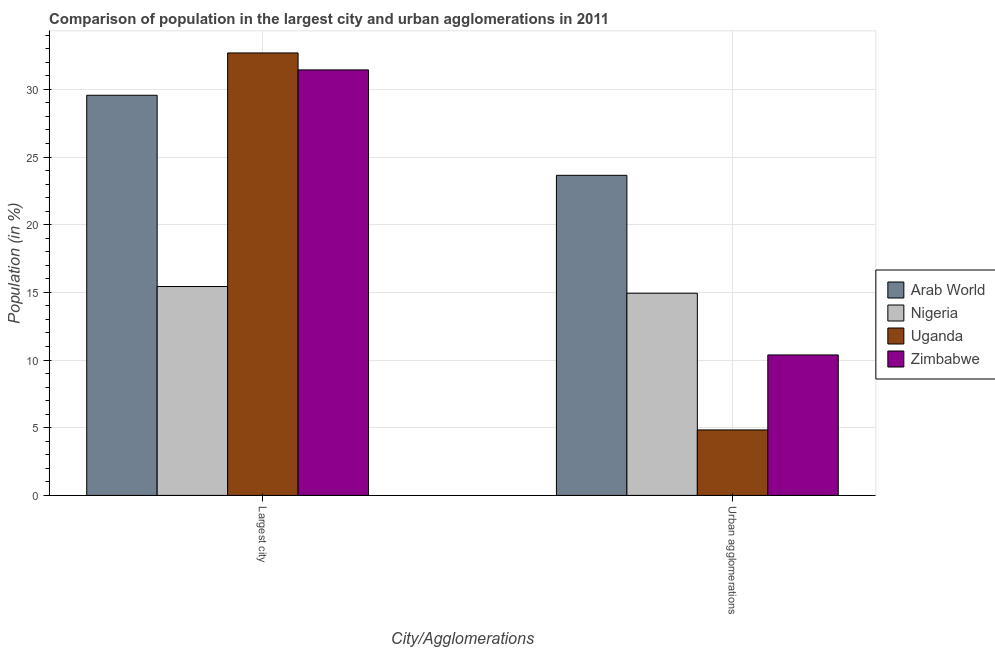Are the number of bars on each tick of the X-axis equal?
Provide a short and direct response. Yes. What is the label of the 1st group of bars from the left?
Your answer should be very brief. Largest city. What is the population in the largest city in Uganda?
Ensure brevity in your answer.  32.69. Across all countries, what is the maximum population in urban agglomerations?
Offer a terse response. 23.65. Across all countries, what is the minimum population in urban agglomerations?
Offer a terse response. 4.84. In which country was the population in the largest city maximum?
Your response must be concise. Uganda. In which country was the population in urban agglomerations minimum?
Offer a very short reply. Uganda. What is the total population in the largest city in the graph?
Your answer should be compact. 109.12. What is the difference between the population in urban agglomerations in Arab World and that in Uganda?
Your answer should be compact. 18.81. What is the difference between the population in the largest city in Arab World and the population in urban agglomerations in Uganda?
Your answer should be very brief. 24.73. What is the average population in the largest city per country?
Offer a terse response. 27.28. What is the difference between the population in urban agglomerations and population in the largest city in Nigeria?
Give a very brief answer. -0.5. What is the ratio of the population in urban agglomerations in Zimbabwe to that in Uganda?
Provide a short and direct response. 2.15. What does the 1st bar from the left in Largest city represents?
Provide a succinct answer. Arab World. What does the 1st bar from the right in Urban agglomerations represents?
Provide a short and direct response. Zimbabwe. How many bars are there?
Ensure brevity in your answer.  8. Are all the bars in the graph horizontal?
Give a very brief answer. No. How many countries are there in the graph?
Provide a succinct answer. 4. Does the graph contain grids?
Provide a succinct answer. Yes. How many legend labels are there?
Make the answer very short. 4. How are the legend labels stacked?
Your answer should be very brief. Vertical. What is the title of the graph?
Your answer should be very brief. Comparison of population in the largest city and urban agglomerations in 2011. What is the label or title of the X-axis?
Provide a short and direct response. City/Agglomerations. What is the label or title of the Y-axis?
Keep it short and to the point. Population (in %). What is the Population (in %) in Arab World in Largest city?
Give a very brief answer. 29.56. What is the Population (in %) of Nigeria in Largest city?
Offer a terse response. 15.43. What is the Population (in %) of Uganda in Largest city?
Give a very brief answer. 32.69. What is the Population (in %) in Zimbabwe in Largest city?
Your answer should be very brief. 31.44. What is the Population (in %) in Arab World in Urban agglomerations?
Give a very brief answer. 23.65. What is the Population (in %) of Nigeria in Urban agglomerations?
Your answer should be compact. 14.94. What is the Population (in %) in Uganda in Urban agglomerations?
Offer a very short reply. 4.84. What is the Population (in %) of Zimbabwe in Urban agglomerations?
Keep it short and to the point. 10.38. Across all City/Agglomerations, what is the maximum Population (in %) of Arab World?
Your response must be concise. 29.56. Across all City/Agglomerations, what is the maximum Population (in %) in Nigeria?
Keep it short and to the point. 15.43. Across all City/Agglomerations, what is the maximum Population (in %) in Uganda?
Offer a terse response. 32.69. Across all City/Agglomerations, what is the maximum Population (in %) of Zimbabwe?
Provide a succinct answer. 31.44. Across all City/Agglomerations, what is the minimum Population (in %) in Arab World?
Keep it short and to the point. 23.65. Across all City/Agglomerations, what is the minimum Population (in %) of Nigeria?
Make the answer very short. 14.94. Across all City/Agglomerations, what is the minimum Population (in %) of Uganda?
Make the answer very short. 4.84. Across all City/Agglomerations, what is the minimum Population (in %) in Zimbabwe?
Your response must be concise. 10.38. What is the total Population (in %) of Arab World in the graph?
Your answer should be compact. 53.21. What is the total Population (in %) in Nigeria in the graph?
Provide a short and direct response. 30.37. What is the total Population (in %) in Uganda in the graph?
Keep it short and to the point. 37.53. What is the total Population (in %) of Zimbabwe in the graph?
Make the answer very short. 41.82. What is the difference between the Population (in %) of Arab World in Largest city and that in Urban agglomerations?
Make the answer very short. 5.91. What is the difference between the Population (in %) in Nigeria in Largest city and that in Urban agglomerations?
Keep it short and to the point. 0.5. What is the difference between the Population (in %) in Uganda in Largest city and that in Urban agglomerations?
Your answer should be very brief. 27.85. What is the difference between the Population (in %) in Zimbabwe in Largest city and that in Urban agglomerations?
Offer a terse response. 21.06. What is the difference between the Population (in %) of Arab World in Largest city and the Population (in %) of Nigeria in Urban agglomerations?
Your answer should be compact. 14.63. What is the difference between the Population (in %) of Arab World in Largest city and the Population (in %) of Uganda in Urban agglomerations?
Offer a very short reply. 24.73. What is the difference between the Population (in %) of Arab World in Largest city and the Population (in %) of Zimbabwe in Urban agglomerations?
Make the answer very short. 19.18. What is the difference between the Population (in %) in Nigeria in Largest city and the Population (in %) in Uganda in Urban agglomerations?
Keep it short and to the point. 10.6. What is the difference between the Population (in %) of Nigeria in Largest city and the Population (in %) of Zimbabwe in Urban agglomerations?
Provide a short and direct response. 5.05. What is the difference between the Population (in %) of Uganda in Largest city and the Population (in %) of Zimbabwe in Urban agglomerations?
Provide a short and direct response. 22.31. What is the average Population (in %) in Arab World per City/Agglomerations?
Ensure brevity in your answer.  26.61. What is the average Population (in %) in Nigeria per City/Agglomerations?
Ensure brevity in your answer.  15.19. What is the average Population (in %) of Uganda per City/Agglomerations?
Give a very brief answer. 18.76. What is the average Population (in %) in Zimbabwe per City/Agglomerations?
Give a very brief answer. 20.91. What is the difference between the Population (in %) in Arab World and Population (in %) in Nigeria in Largest city?
Make the answer very short. 14.13. What is the difference between the Population (in %) of Arab World and Population (in %) of Uganda in Largest city?
Give a very brief answer. -3.13. What is the difference between the Population (in %) of Arab World and Population (in %) of Zimbabwe in Largest city?
Keep it short and to the point. -1.87. What is the difference between the Population (in %) in Nigeria and Population (in %) in Uganda in Largest city?
Make the answer very short. -17.26. What is the difference between the Population (in %) in Nigeria and Population (in %) in Zimbabwe in Largest city?
Ensure brevity in your answer.  -16. What is the difference between the Population (in %) in Uganda and Population (in %) in Zimbabwe in Largest city?
Give a very brief answer. 1.25. What is the difference between the Population (in %) of Arab World and Population (in %) of Nigeria in Urban agglomerations?
Offer a terse response. 8.71. What is the difference between the Population (in %) of Arab World and Population (in %) of Uganda in Urban agglomerations?
Give a very brief answer. 18.81. What is the difference between the Population (in %) in Arab World and Population (in %) in Zimbabwe in Urban agglomerations?
Ensure brevity in your answer.  13.27. What is the difference between the Population (in %) of Nigeria and Population (in %) of Uganda in Urban agglomerations?
Make the answer very short. 10.1. What is the difference between the Population (in %) of Nigeria and Population (in %) of Zimbabwe in Urban agglomerations?
Keep it short and to the point. 4.56. What is the difference between the Population (in %) of Uganda and Population (in %) of Zimbabwe in Urban agglomerations?
Your answer should be compact. -5.54. What is the ratio of the Population (in %) in Arab World in Largest city to that in Urban agglomerations?
Ensure brevity in your answer.  1.25. What is the ratio of the Population (in %) of Nigeria in Largest city to that in Urban agglomerations?
Your answer should be compact. 1.03. What is the ratio of the Population (in %) in Uganda in Largest city to that in Urban agglomerations?
Your response must be concise. 6.76. What is the ratio of the Population (in %) of Zimbabwe in Largest city to that in Urban agglomerations?
Offer a terse response. 3.03. What is the difference between the highest and the second highest Population (in %) of Arab World?
Provide a succinct answer. 5.91. What is the difference between the highest and the second highest Population (in %) of Nigeria?
Ensure brevity in your answer.  0.5. What is the difference between the highest and the second highest Population (in %) of Uganda?
Ensure brevity in your answer.  27.85. What is the difference between the highest and the second highest Population (in %) of Zimbabwe?
Your response must be concise. 21.06. What is the difference between the highest and the lowest Population (in %) in Arab World?
Give a very brief answer. 5.91. What is the difference between the highest and the lowest Population (in %) of Nigeria?
Make the answer very short. 0.5. What is the difference between the highest and the lowest Population (in %) of Uganda?
Provide a short and direct response. 27.85. What is the difference between the highest and the lowest Population (in %) in Zimbabwe?
Offer a very short reply. 21.06. 